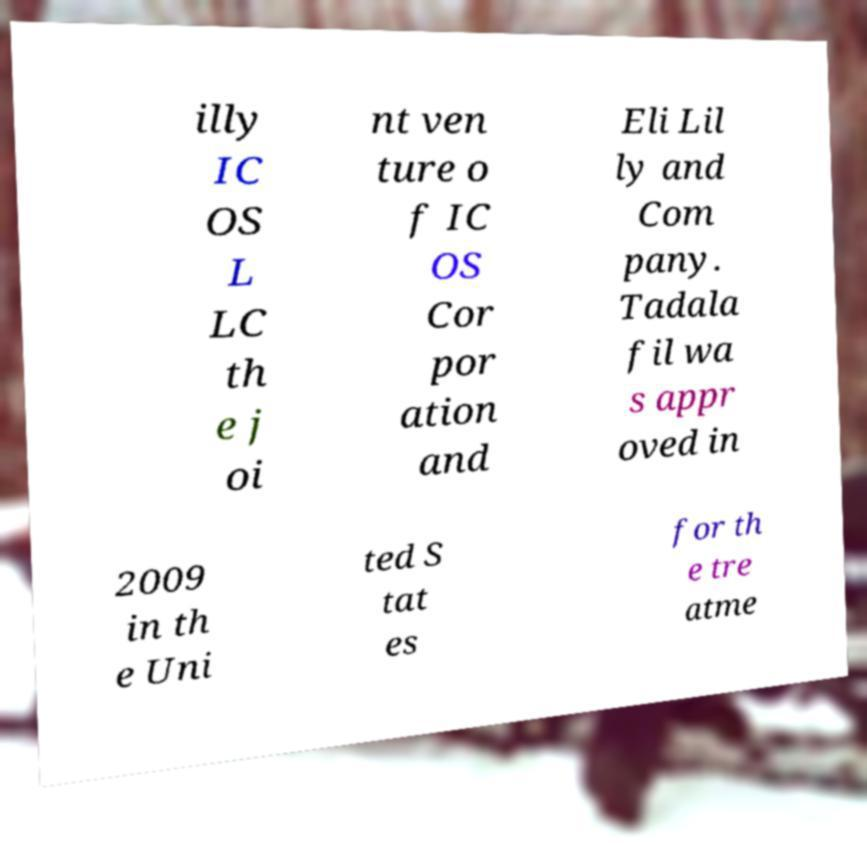There's text embedded in this image that I need extracted. Can you transcribe it verbatim? illy IC OS L LC th e j oi nt ven ture o f IC OS Cor por ation and Eli Lil ly and Com pany. Tadala fil wa s appr oved in 2009 in th e Uni ted S tat es for th e tre atme 